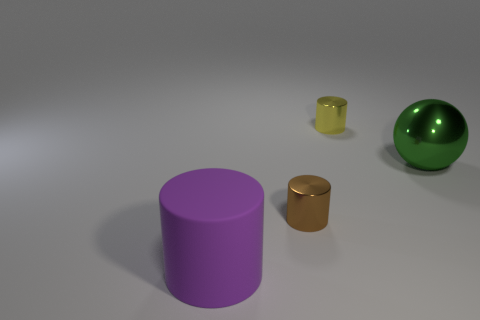Is the number of large green things less than the number of tiny green shiny blocks?
Ensure brevity in your answer.  No. What size is the object to the right of the shiny cylinder behind the tiny brown cylinder?
Keep it short and to the point. Large. The small metallic object in front of the big object that is behind the cylinder left of the brown thing is what shape?
Keep it short and to the point. Cylinder. There is another cylinder that is made of the same material as the yellow cylinder; what color is it?
Your answer should be compact. Brown. What color is the thing that is on the right side of the small thing that is behind the small shiny object in front of the tiny yellow cylinder?
Keep it short and to the point. Green. How many cylinders are large purple objects or yellow objects?
Your response must be concise. 2. What color is the big ball?
Provide a succinct answer. Green. How many objects are tiny yellow things or big matte cylinders?
Your answer should be very brief. 2. What is the material of the thing that is the same size as the green metal sphere?
Make the answer very short. Rubber. There is a thing right of the yellow metallic cylinder; how big is it?
Your answer should be compact. Large. 